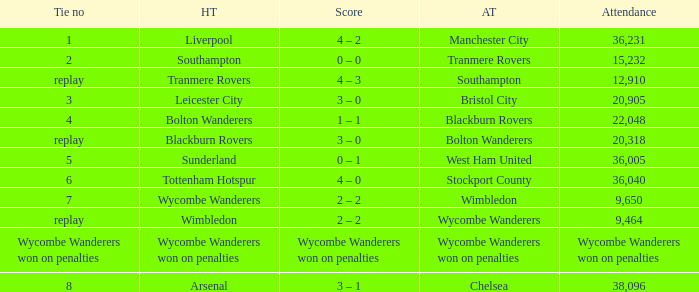What was the score of having a tie of 1? 4 – 2. 